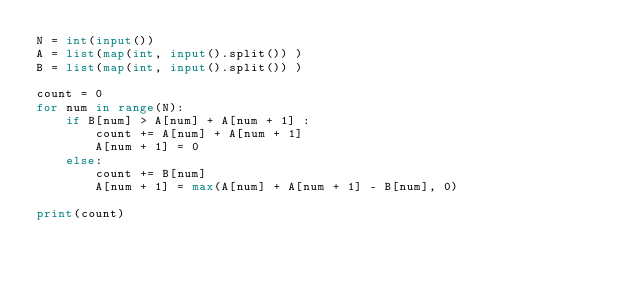<code> <loc_0><loc_0><loc_500><loc_500><_Python_>N = int(input())
A = list(map(int, input().split()) )
B = list(map(int, input().split()) )

count = 0
for num in range(N):
    if B[num] > A[num] + A[num + 1] :
        count += A[num] + A[num + 1]
        A[num + 1] = 0
    else:
        count += B[num]
        A[num + 1] = max(A[num] + A[num + 1] - B[num], 0)

print(count)</code> 